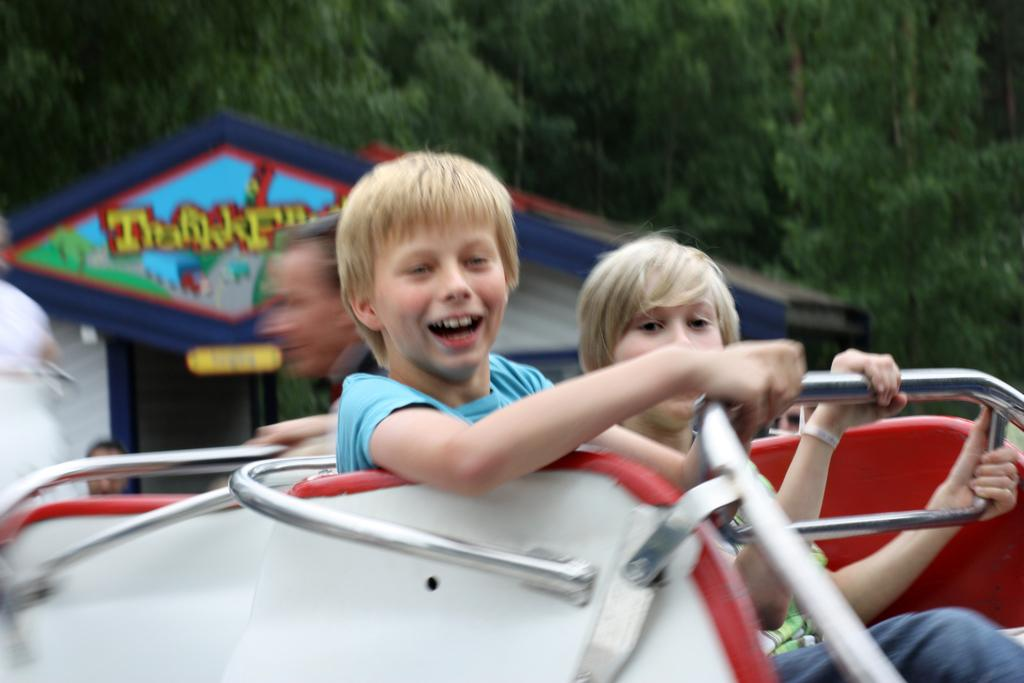What are the children in the image doing? The children are in a fun ride. Can you describe the background of the image? There are persons, a shed, and trees in the background. What type of list can be seen in the image? There is no list present in the image. 